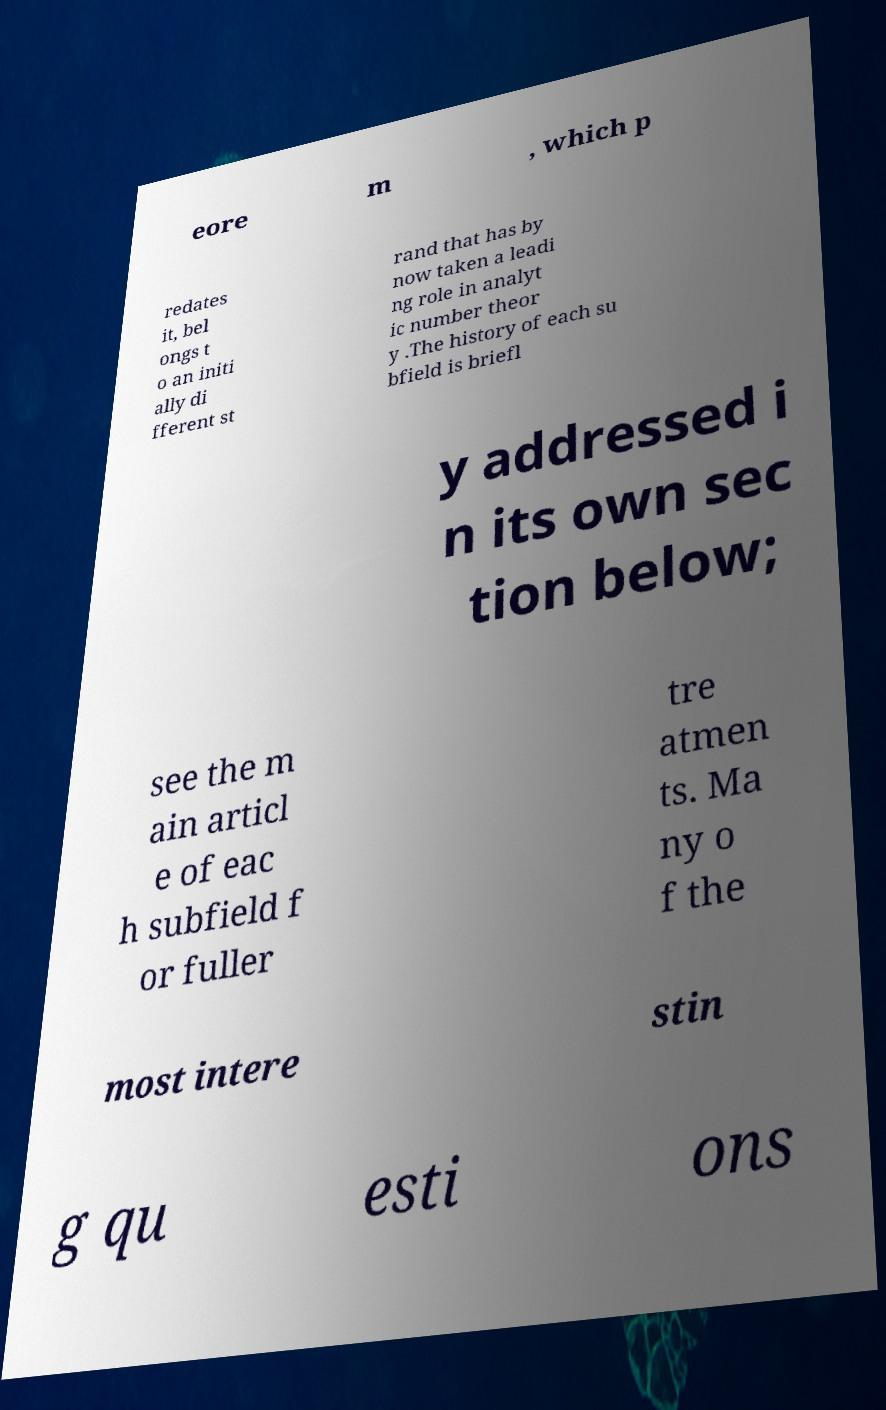I need the written content from this picture converted into text. Can you do that? eore m , which p redates it, bel ongs t o an initi ally di fferent st rand that has by now taken a leadi ng role in analyt ic number theor y .The history of each su bfield is briefl y addressed i n its own sec tion below; see the m ain articl e of eac h subfield f or fuller tre atmen ts. Ma ny o f the most intere stin g qu esti ons 